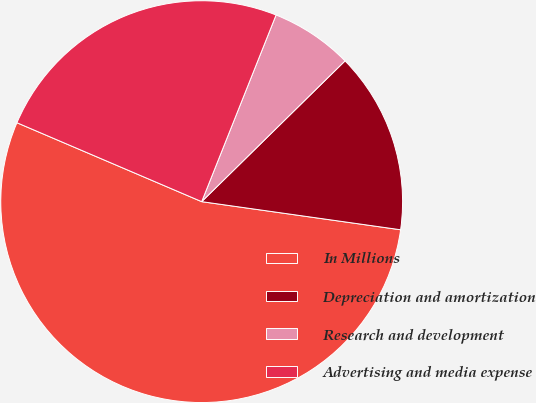Convert chart. <chart><loc_0><loc_0><loc_500><loc_500><pie_chart><fcel>In Millions<fcel>Depreciation and amortization<fcel>Research and development<fcel>Advertising and media expense<nl><fcel>54.19%<fcel>14.59%<fcel>6.61%<fcel>24.61%<nl></chart> 